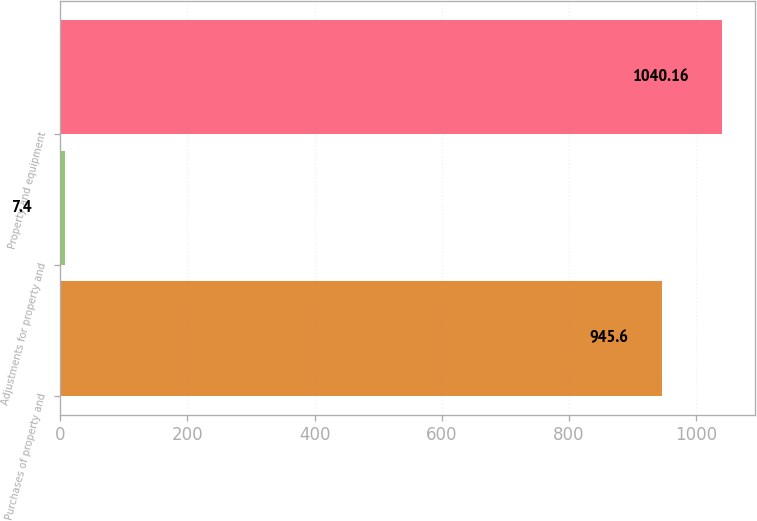Convert chart. <chart><loc_0><loc_0><loc_500><loc_500><bar_chart><fcel>Purchases of property and<fcel>Adjustments for property and<fcel>Property and equipment<nl><fcel>945.6<fcel>7.4<fcel>1040.16<nl></chart> 